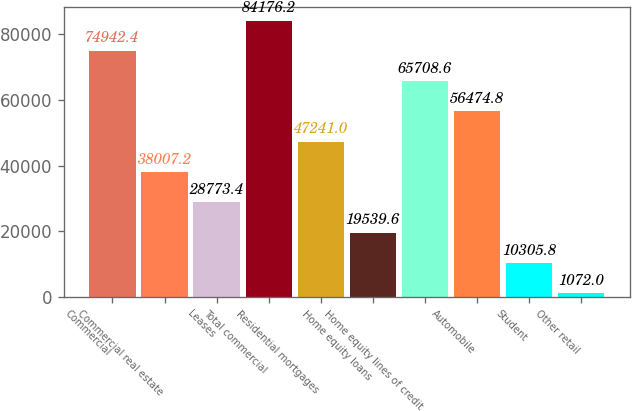Convert chart to OTSL. <chart><loc_0><loc_0><loc_500><loc_500><bar_chart><fcel>Commercial<fcel>Commercial real estate<fcel>Leases<fcel>Total commercial<fcel>Residential mortgages<fcel>Home equity loans<fcel>Home equity lines of credit<fcel>Automobile<fcel>Student<fcel>Other retail<nl><fcel>74942.4<fcel>38007.2<fcel>28773.4<fcel>84176.2<fcel>47241<fcel>19539.6<fcel>65708.6<fcel>56474.8<fcel>10305.8<fcel>1072<nl></chart> 